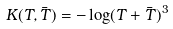<formula> <loc_0><loc_0><loc_500><loc_500>K ( T , \bar { T } ) = - \log ( T + \bar { T } ) ^ { 3 }</formula> 